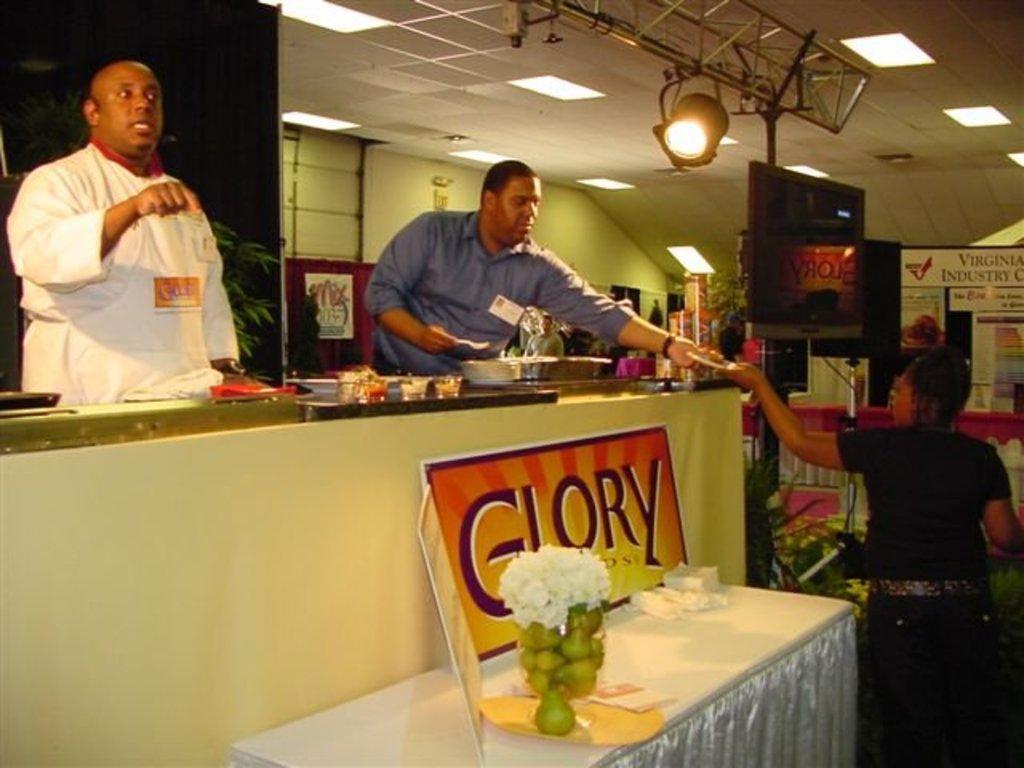In one or two sentences, can you explain what this image depicts? In this image in front there is a table. On top of the table there are flowers, tissues, boards. Beside the table there is a person. Behind the table there is another table and on top of it there are cups and a few other objects. Behind the table there are two people. On the right side of the image there is a TV. There are a table and boards. On top of the image there are lights. 